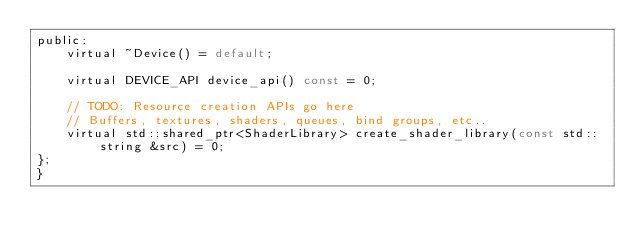Convert code to text. <code><loc_0><loc_0><loc_500><loc_500><_C_>public:
    virtual ~Device() = default;

    virtual DEVICE_API device_api() const = 0;

    // TODO: Resource creation APIs go here
    // Buffers, textures, shaders, queues, bind groups, etc..
    virtual std::shared_ptr<ShaderLibrary> create_shader_library(const std::string &src) = 0;
};
}
</code> 